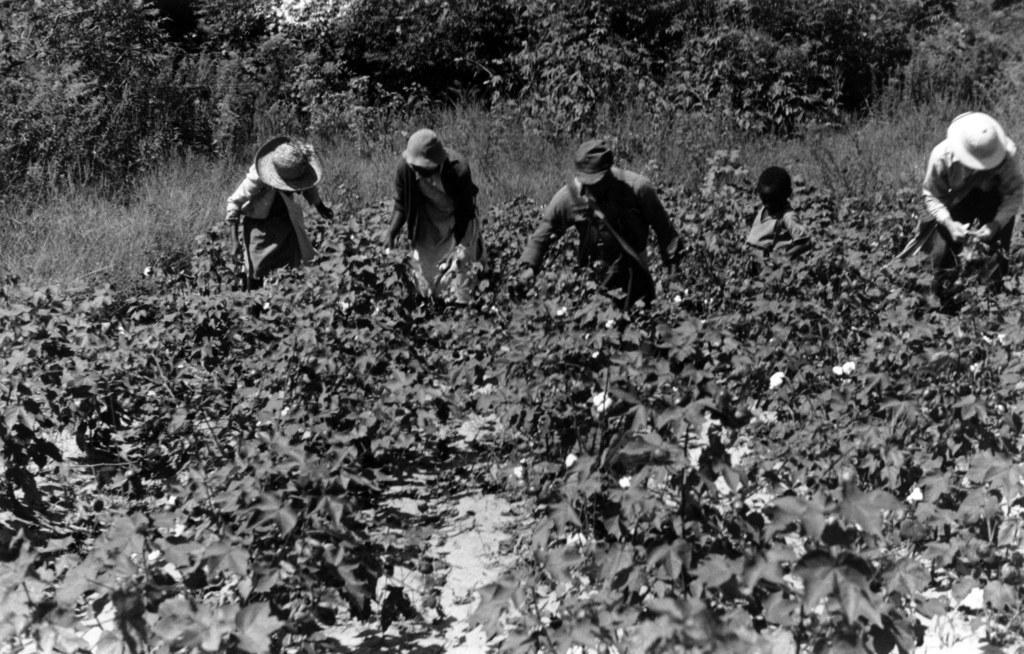Describe this image in one or two sentences. In this picture we can see some plants from left to right. Few people are visible on the path. We can see some trees in the background. 